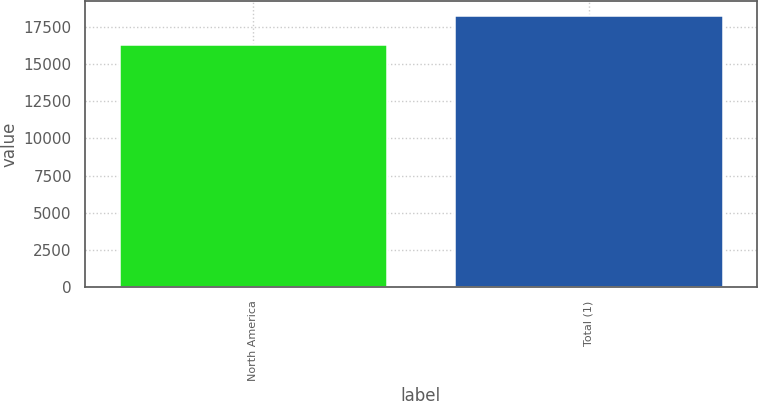<chart> <loc_0><loc_0><loc_500><loc_500><bar_chart><fcel>North America<fcel>Total (1)<nl><fcel>16349.2<fcel>18289<nl></chart> 